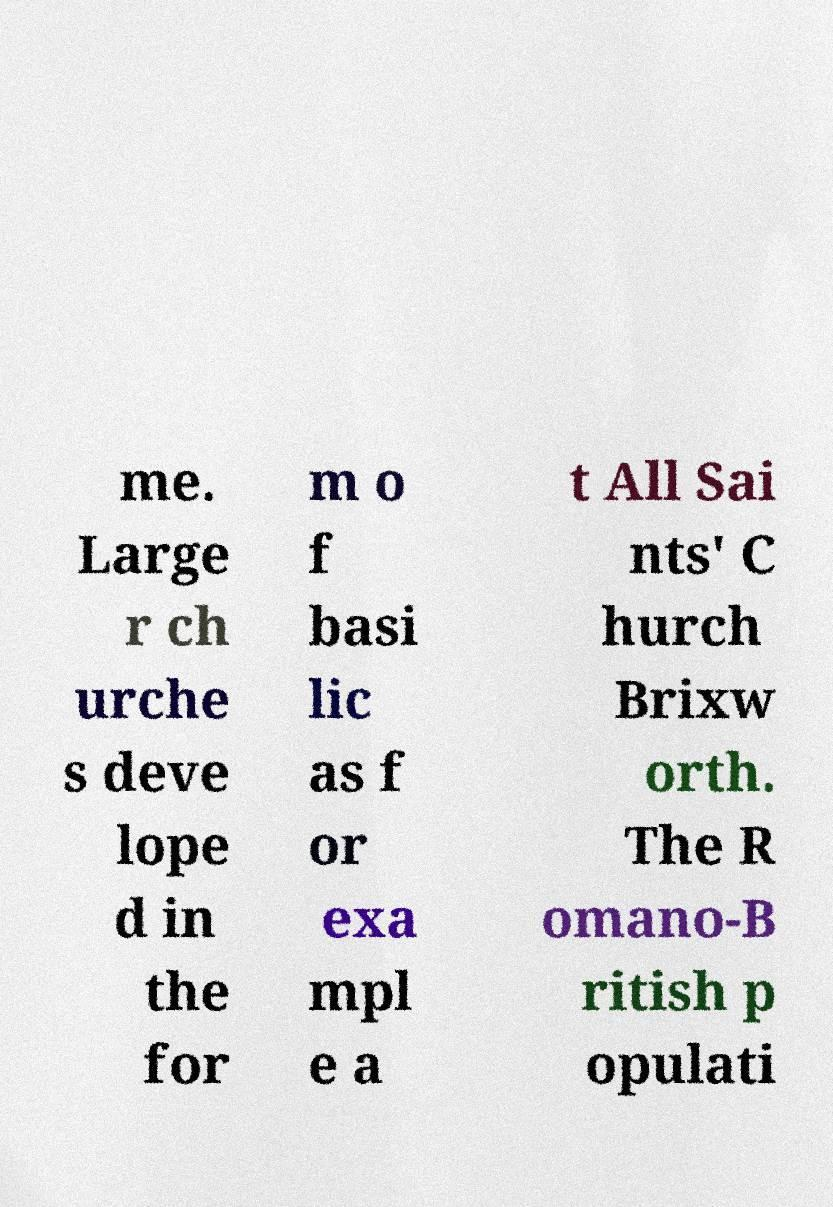Please identify and transcribe the text found in this image. me. Large r ch urche s deve lope d in the for m o f basi lic as f or exa mpl e a t All Sai nts' C hurch Brixw orth. The R omano-B ritish p opulati 